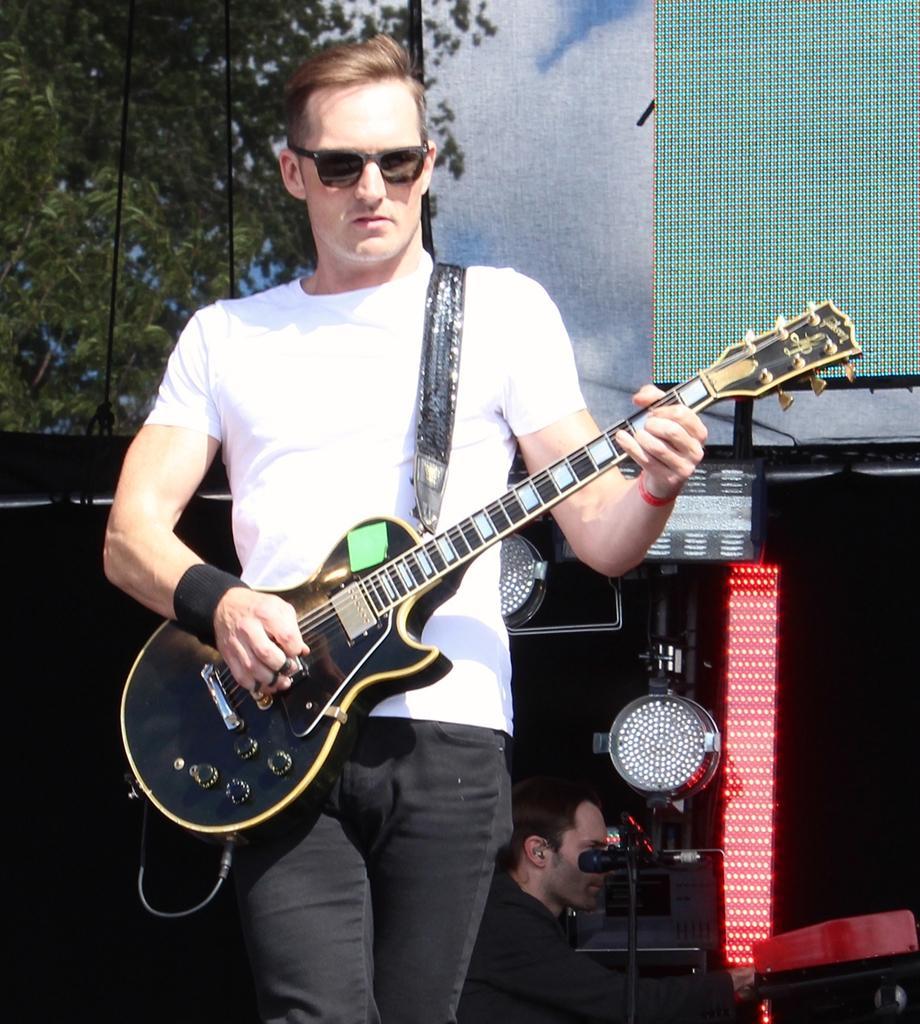Describe this image in one or two sentences. In this image, In the middle there is a boy standing and he is holding a music instrument which is in black color, In the background there is a man sitting and there are some music instruments which are in black and red color, In the background in the top there is a green color object, There are some trees in green color. 